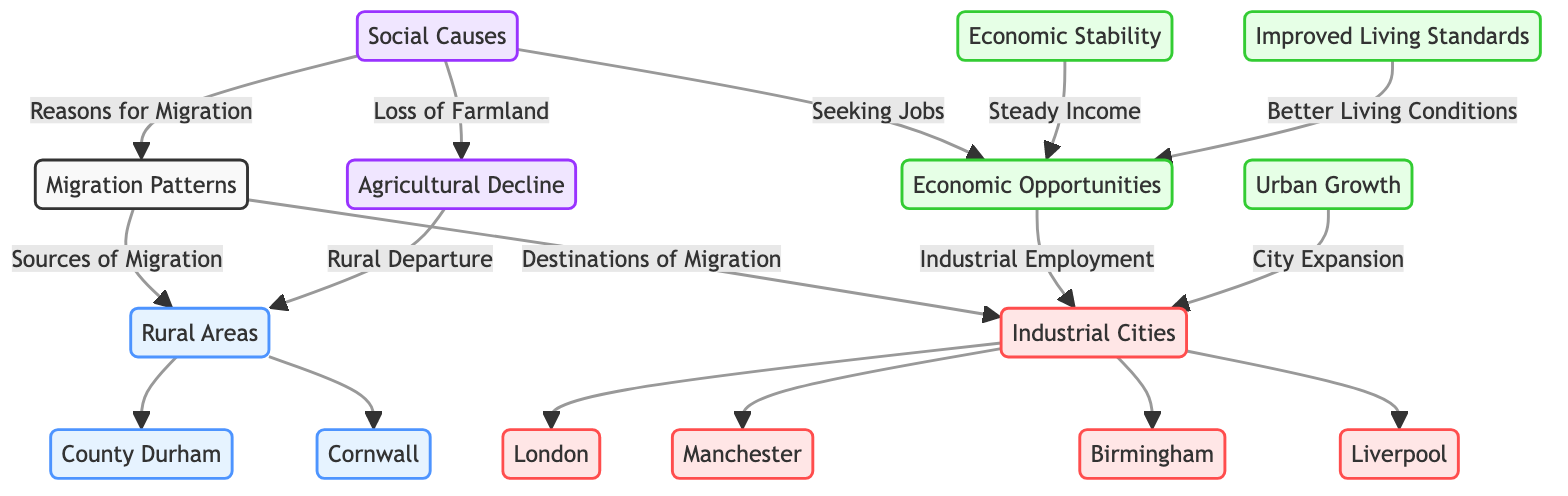What are the sources of migration in the diagram? The diagram lists rural areas as the sources of migration. Looking at the connection from "Migration Patterns" to "Rural Areas," we see areas like County Durham and Cornwall as direct sources.
Answer: Rural Areas Which industrial city is mentioned as a destination for migration? The diagram identifies multiple cities, with Manchester prominently listed as a destination for migration. Tracing from "Industrial Cities," we see Manchester directly linked.
Answer: Manchester How many urban cities are indicated as destinations? The diagram lists four urban cities: London, Manchester, Birmingham, and Liverpool. By counting the connecting nodes under "Industrial Cities," we confirm there are four listed destinations.
Answer: Four What social cause is associated with loss of farmland? The diagram connects "Loss of Farmland" to "Agricultural Decline" as a social cause. The flow goes from social reasons to specific causes of migration, linking these two concepts.
Answer: Agricultural Decline What effect is linked to city expansion according to the diagram? The diagram shows that city expansion is connected to "Urban Growth." Following the arrows, we see the flow from city expansion leading to the result of increased growth in urban areas.
Answer: Urban Growth How does improved living standards relate to migration patterns? The diagram links "Improved Living Standards" as an effect of migration from rural areas to industrial cities. This connection shows that seeking better conditions is a motivator behind migration.
Answer: Improved Living Standards What is the primary reason individuals migrate according to the diagram? The primary reason identified in the diagram is "Seeking Jobs." This reason acts as a central node pointing towards various economic opportunities that motivate migration patterns.
Answer: Seeking Jobs Which rural area is highlighted in the diagram? County Durham is explicitly mentioned as one of the rural areas. It is listed under the "Rural Areas" node and directly connected to the source of migration.
Answer: County Durham What is the relationship between economic stability and industrial employment? The diagram shows that economic stability is connected to "Industrial Employment." This indicates that having a steady income from industrial jobs is a reason behind the migration patterns depicted.
Answer: Industrial Employment 